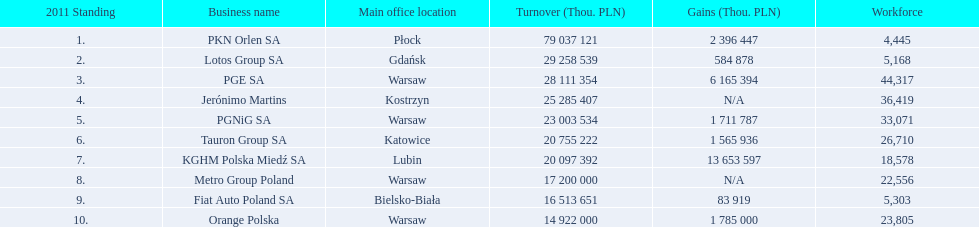What companies are listed? PKN Orlen SA, Lotos Group SA, PGE SA, Jerónimo Martins, PGNiG SA, Tauron Group SA, KGHM Polska Miedź SA, Metro Group Poland, Fiat Auto Poland SA, Orange Polska. What are the company's revenues? 79 037 121, 29 258 539, 28 111 354, 25 285 407, 23 003 534, 20 755 222, 20 097 392, 17 200 000, 16 513 651, 14 922 000. Which company has the greatest revenue? PKN Orlen SA. 